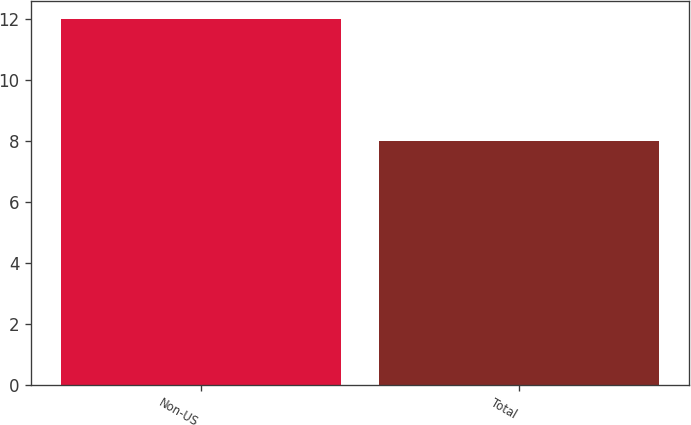Convert chart to OTSL. <chart><loc_0><loc_0><loc_500><loc_500><bar_chart><fcel>Non-US<fcel>Total<nl><fcel>12<fcel>8<nl></chart> 